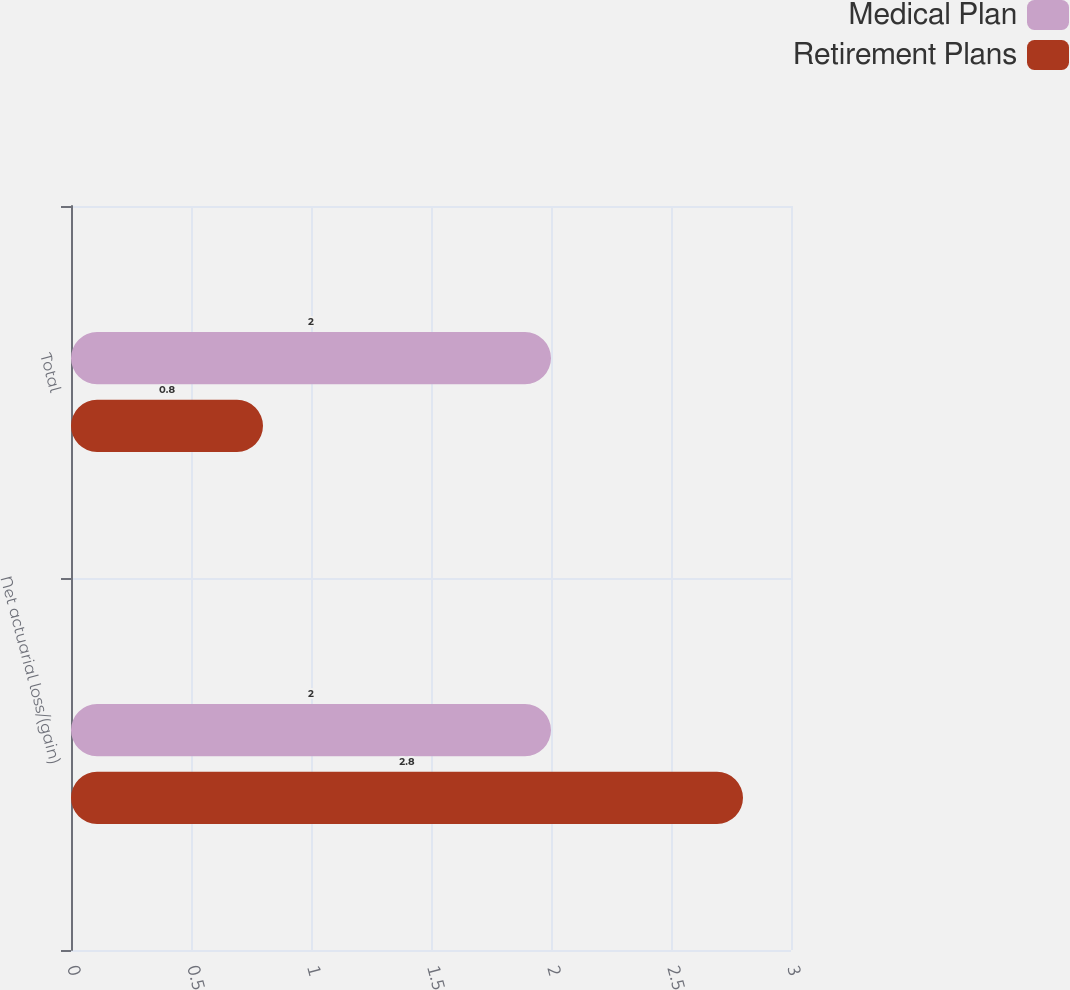<chart> <loc_0><loc_0><loc_500><loc_500><stacked_bar_chart><ecel><fcel>Net actuarial loss/(gain)<fcel>Total<nl><fcel>Medical Plan<fcel>2<fcel>2<nl><fcel>Retirement Plans<fcel>2.8<fcel>0.8<nl></chart> 